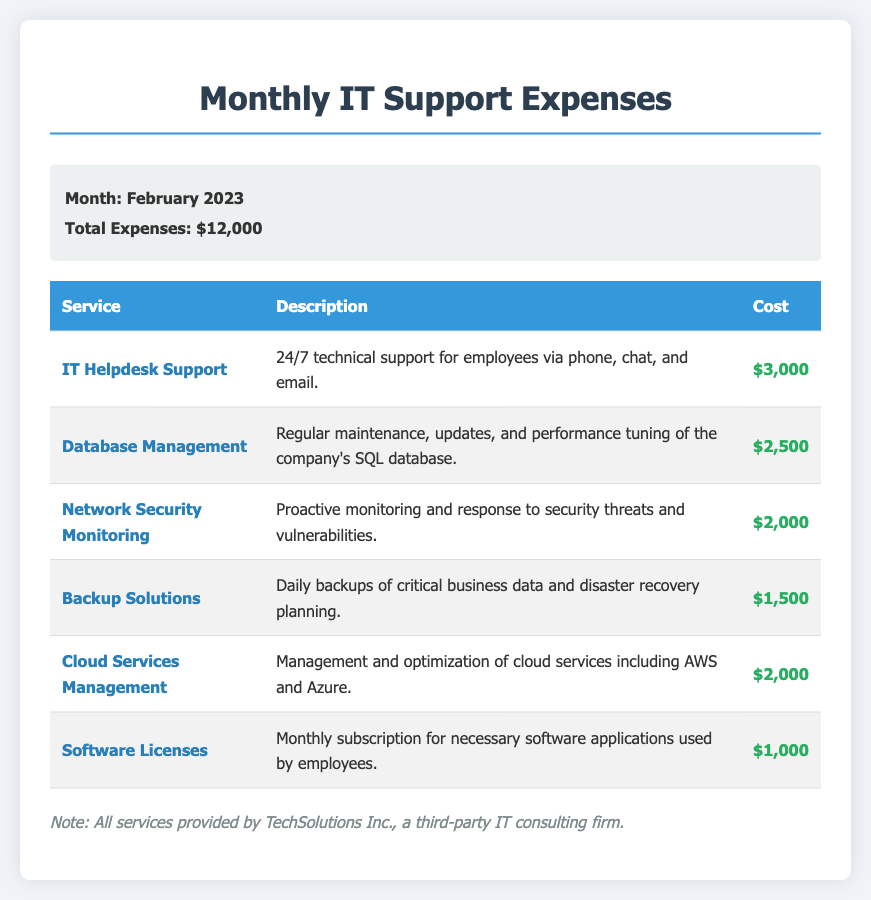What is the total amount of expenses for February 2023? The total expenses are stated directly in the document as $12,000.
Answer: $12,000 How much does IT Helpdesk Support cost? The cost for IT Helpdesk Support is listed in the table as $3,000.
Answer: $3,000 What service is provided for daily backups? The service that handles daily backups is called Backup Solutions, as mentioned in the expense table.
Answer: Backup Solutions What is the cost associated with Database Management? The cost for Database Management is specified in the document as $2,500.
Answer: $2,500 Which company provides the IT services mentioned? The document states that all services are provided by TechSolutions Inc.
Answer: TechSolutions Inc How much does the company spend on Software Licenses? The expense for Software Licenses is mentioned as $1,000 in the budget breakdown.
Answer: $1,000 What type of monitoring is included in Network Security Monitoring? The document describes the service as proactive monitoring of security threats and vulnerabilities.
Answer: Security Monitoring Which service includes management of AWS and Azure? The service related to management of AWS and Azure is Cloud Services Management according to the document.
Answer: Cloud Services Management What is the cost for Backup Solutions? According to the table, Backup Solutions costs $1,500.
Answer: $1,500 